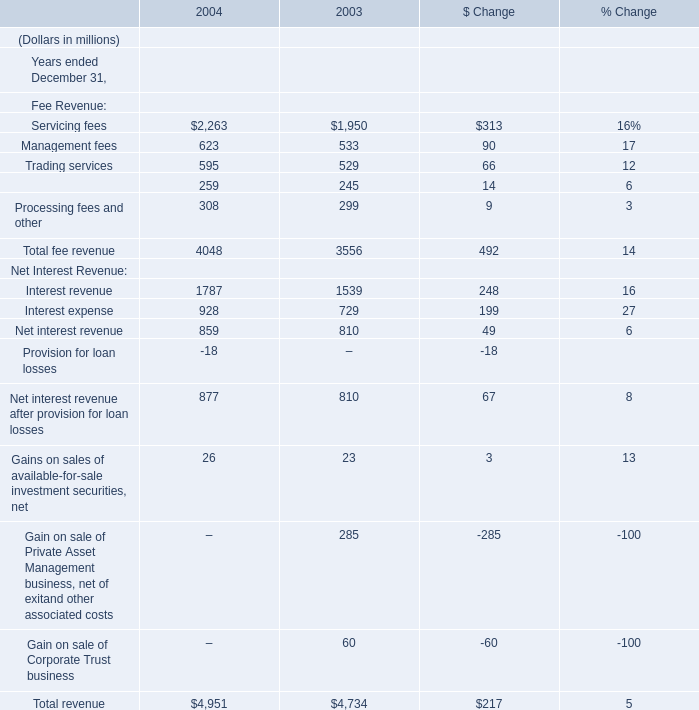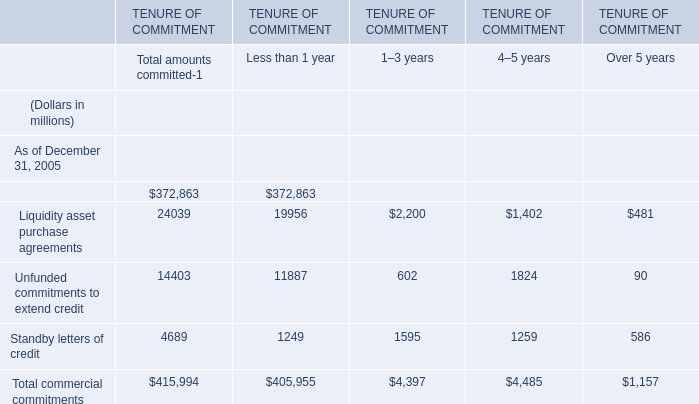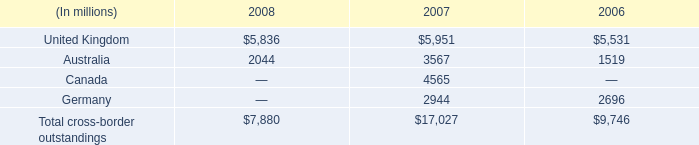What was the total amount of Trading services,Securities finance, Interest revenue and Interest expense in 2003 ? (in million) 
Computations: (((529 + 245) + 1539) + 729)
Answer: 3042.0. 